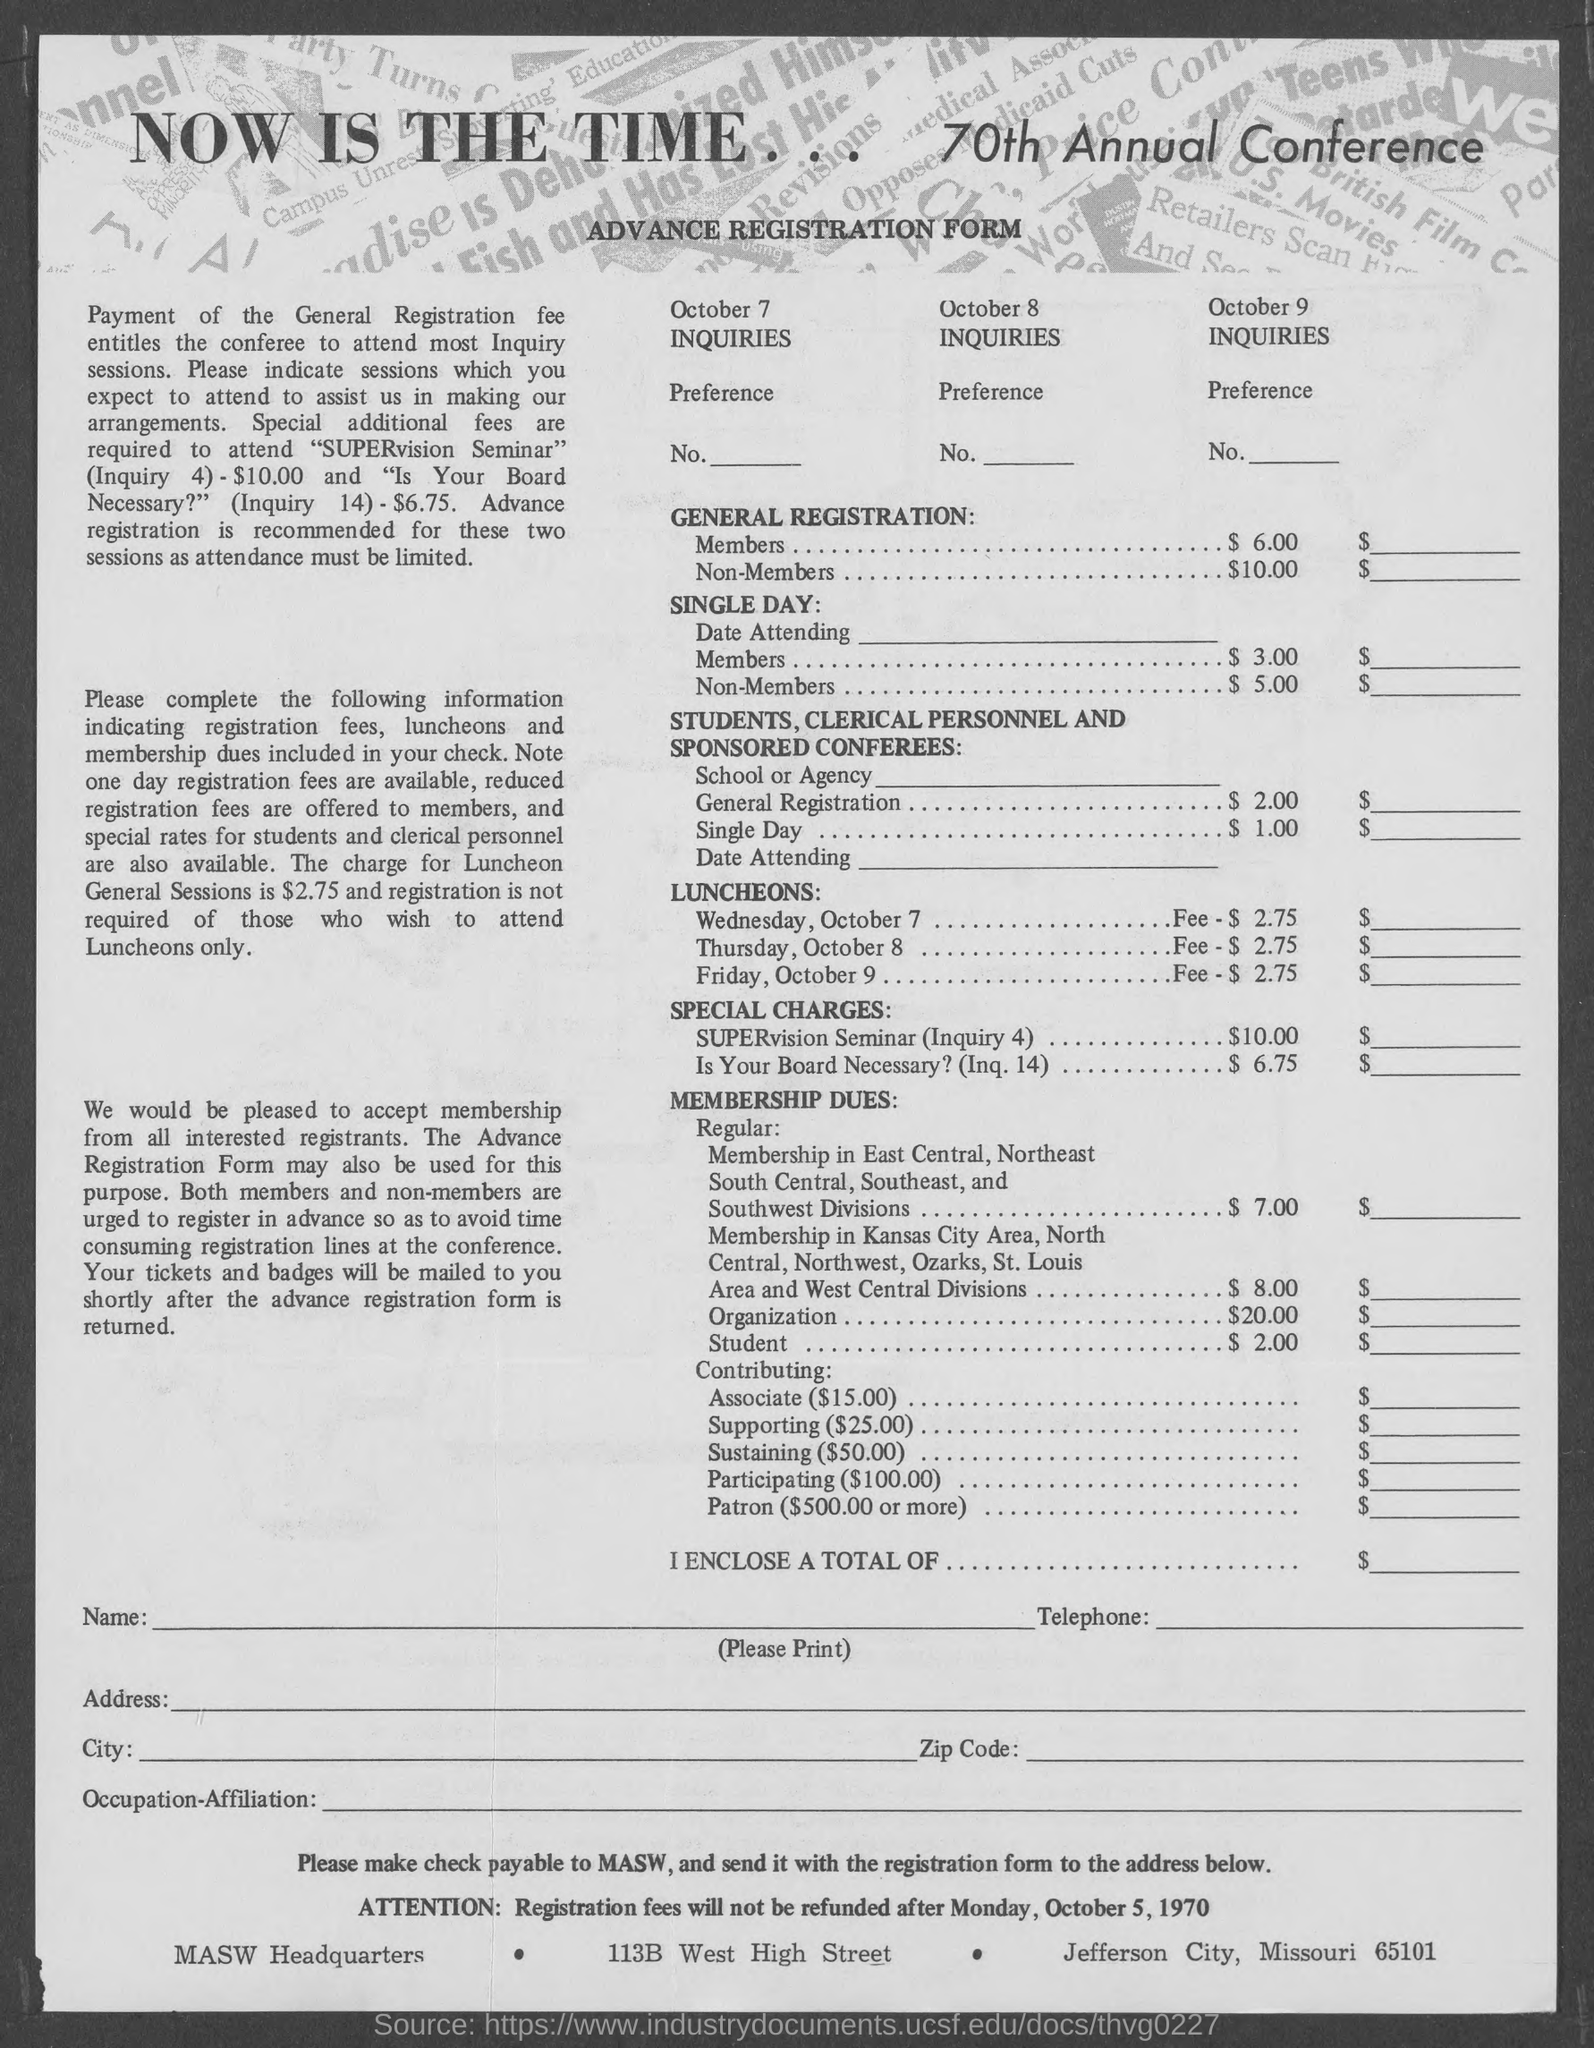What is the name of the form?
Make the answer very short. Advance Registration Form. What is the charge for general registration for members ?
Keep it short and to the point. $6.00. What is the charge for general registration of non-members ?
Make the answer very short. $10.00. 